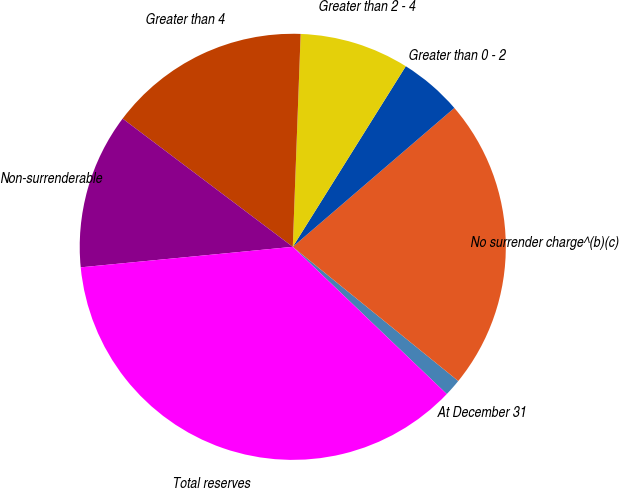Convert chart to OTSL. <chart><loc_0><loc_0><loc_500><loc_500><pie_chart><fcel>At December 31<fcel>No surrender charge^(b)(c)<fcel>Greater than 0 - 2<fcel>Greater than 2 - 4<fcel>Greater than 4<fcel>Non-surrenderable<fcel>Total reserves<nl><fcel>1.3%<fcel>22.14%<fcel>4.8%<fcel>8.31%<fcel>15.31%<fcel>11.81%<fcel>36.32%<nl></chart> 